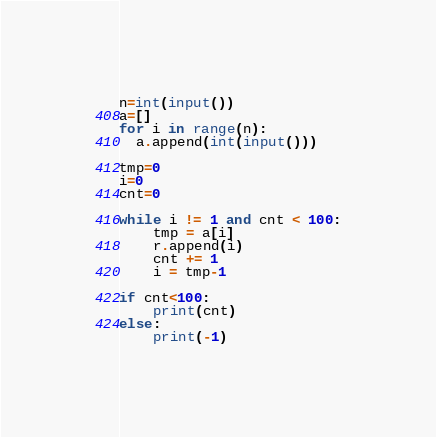Convert code to text. <code><loc_0><loc_0><loc_500><loc_500><_Python_>n=int(input())
a=[]
for i in range(n):
  a.append(int(input()))

tmp=0
i=0
cnt=0

while i != 1 and cnt < 100:
    tmp = a[i]
    r.append(i)
    cnt += 1
    i = tmp-1

if cnt<100:
    print(cnt)
else:
    print(-1)
</code> 